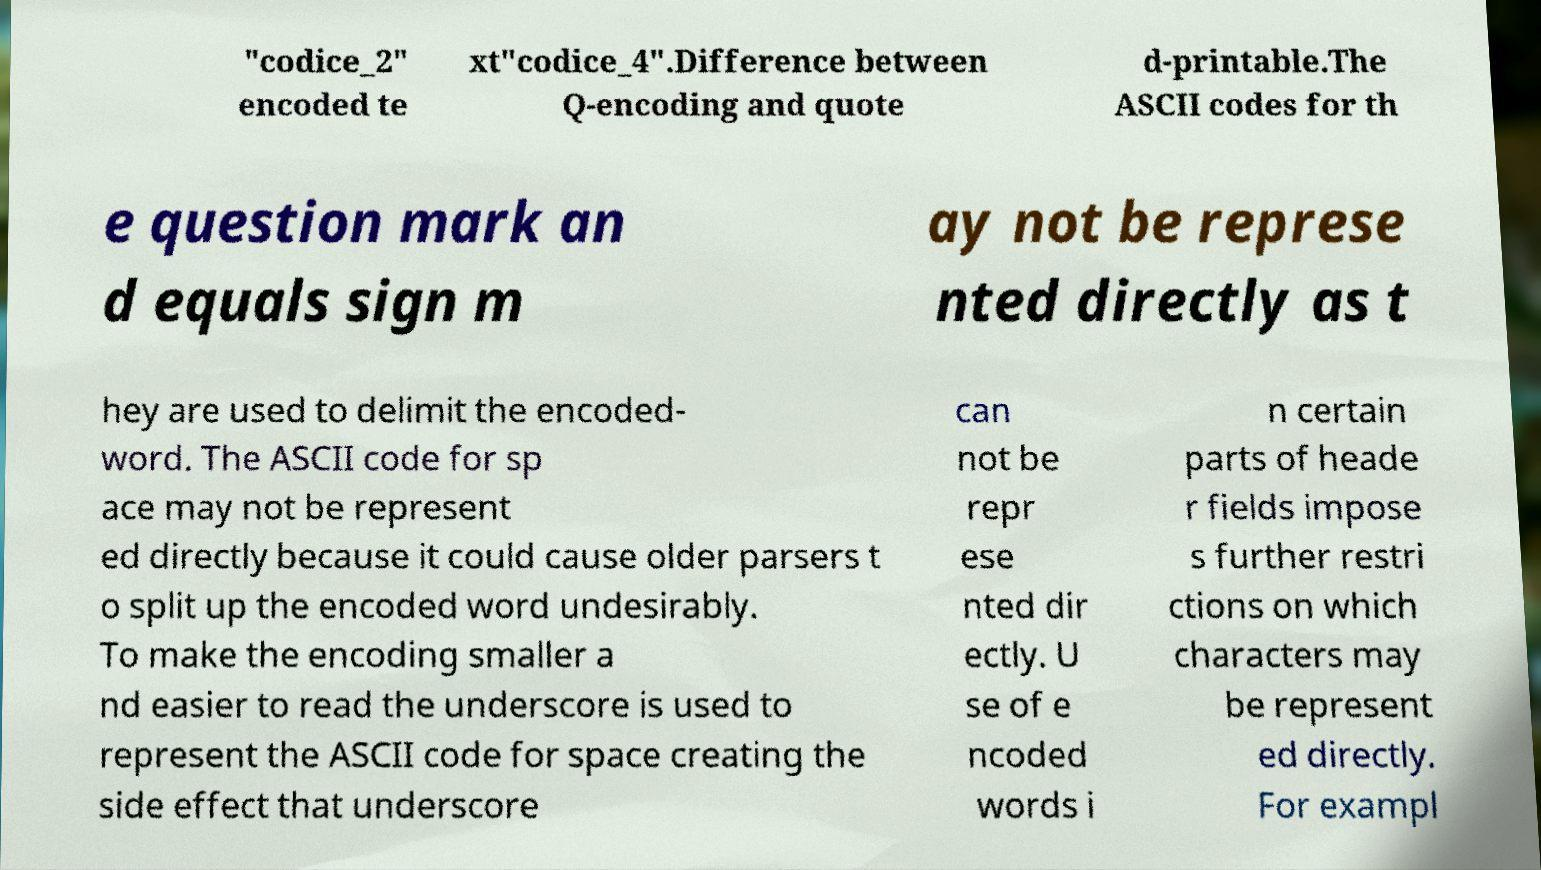Can you accurately transcribe the text from the provided image for me? "codice_2" encoded te xt"codice_4".Difference between Q-encoding and quote d-printable.The ASCII codes for th e question mark an d equals sign m ay not be represe nted directly as t hey are used to delimit the encoded- word. The ASCII code for sp ace may not be represent ed directly because it could cause older parsers t o split up the encoded word undesirably. To make the encoding smaller a nd easier to read the underscore is used to represent the ASCII code for space creating the side effect that underscore can not be repr ese nted dir ectly. U se of e ncoded words i n certain parts of heade r fields impose s further restri ctions on which characters may be represent ed directly. For exampl 